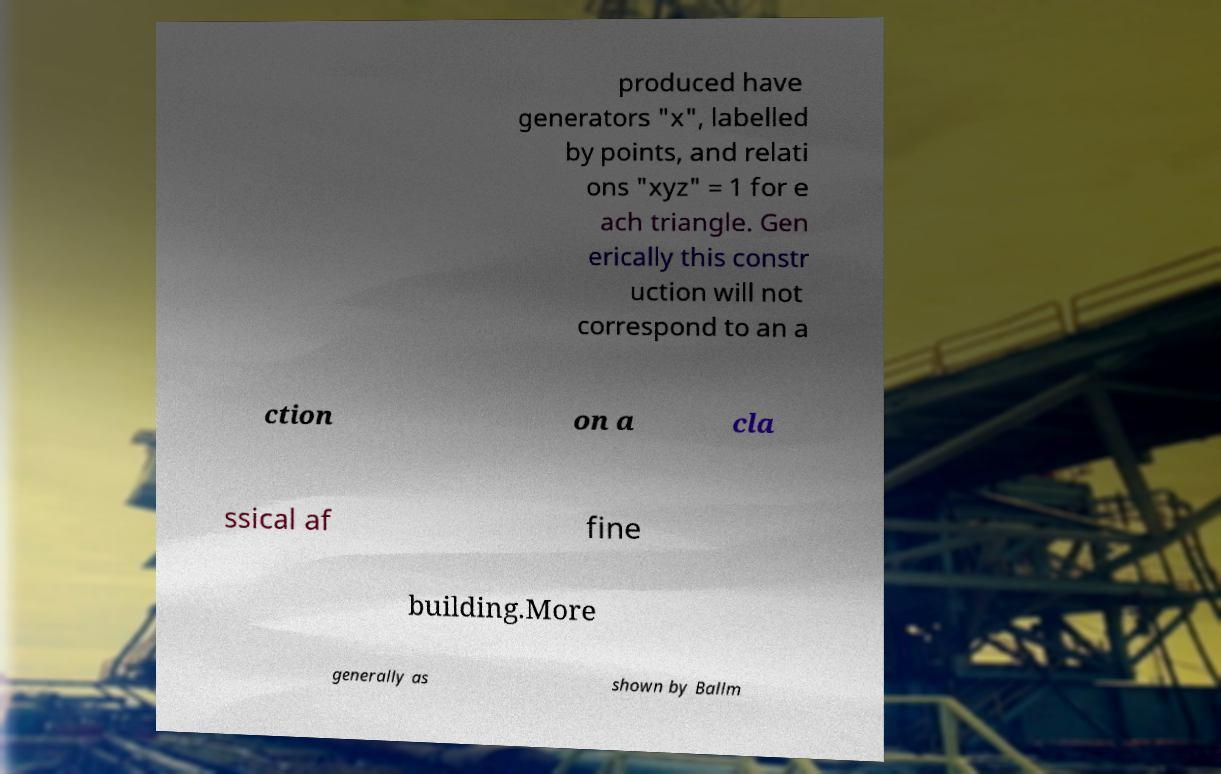Can you accurately transcribe the text from the provided image for me? produced have generators "x", labelled by points, and relati ons "xyz" = 1 for e ach triangle. Gen erically this constr uction will not correspond to an a ction on a cla ssical af fine building.More generally as shown by Ballm 